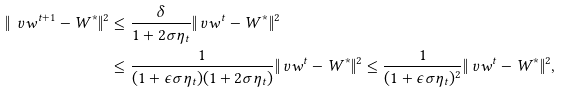<formula> <loc_0><loc_0><loc_500><loc_500>\| \ v w ^ { t + 1 } - W ^ { \ast } \| ^ { 2 } & \leq \frac { \delta } { 1 + 2 \sigma \eta _ { t } } \| \ v w ^ { t } - W ^ { \ast } \| ^ { 2 } \\ & \leq \frac { 1 } { ( 1 + \epsilon \sigma \eta _ { t } ) ( 1 + 2 \sigma \eta _ { t } ) } \| \ v w ^ { t } - W ^ { \ast } \| ^ { 2 } \leq \frac { 1 } { ( 1 + \epsilon \sigma \eta _ { t } ) ^ { 2 } } \| \ v w ^ { t } - W ^ { \ast } \| ^ { 2 } ,</formula> 